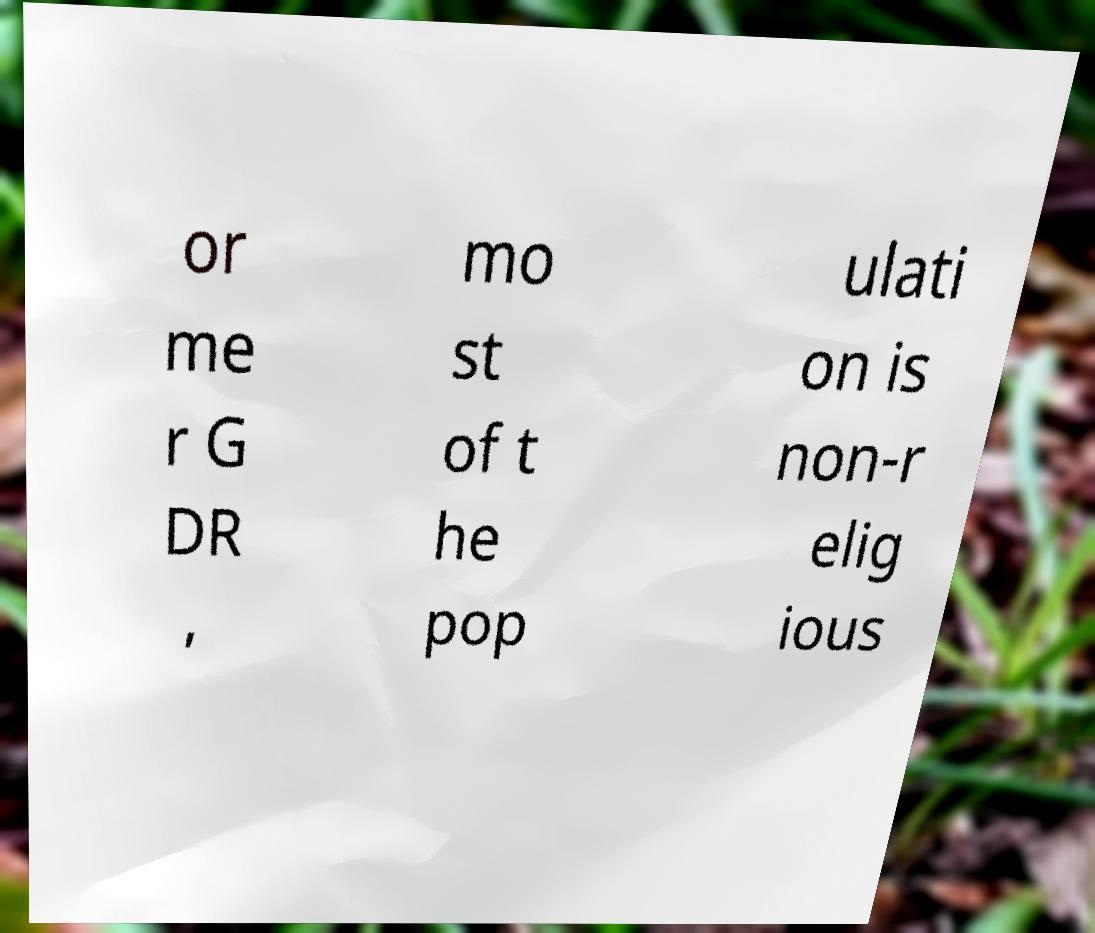Can you read and provide the text displayed in the image?This photo seems to have some interesting text. Can you extract and type it out for me? or me r G DR , mo st of t he pop ulati on is non-r elig ious 